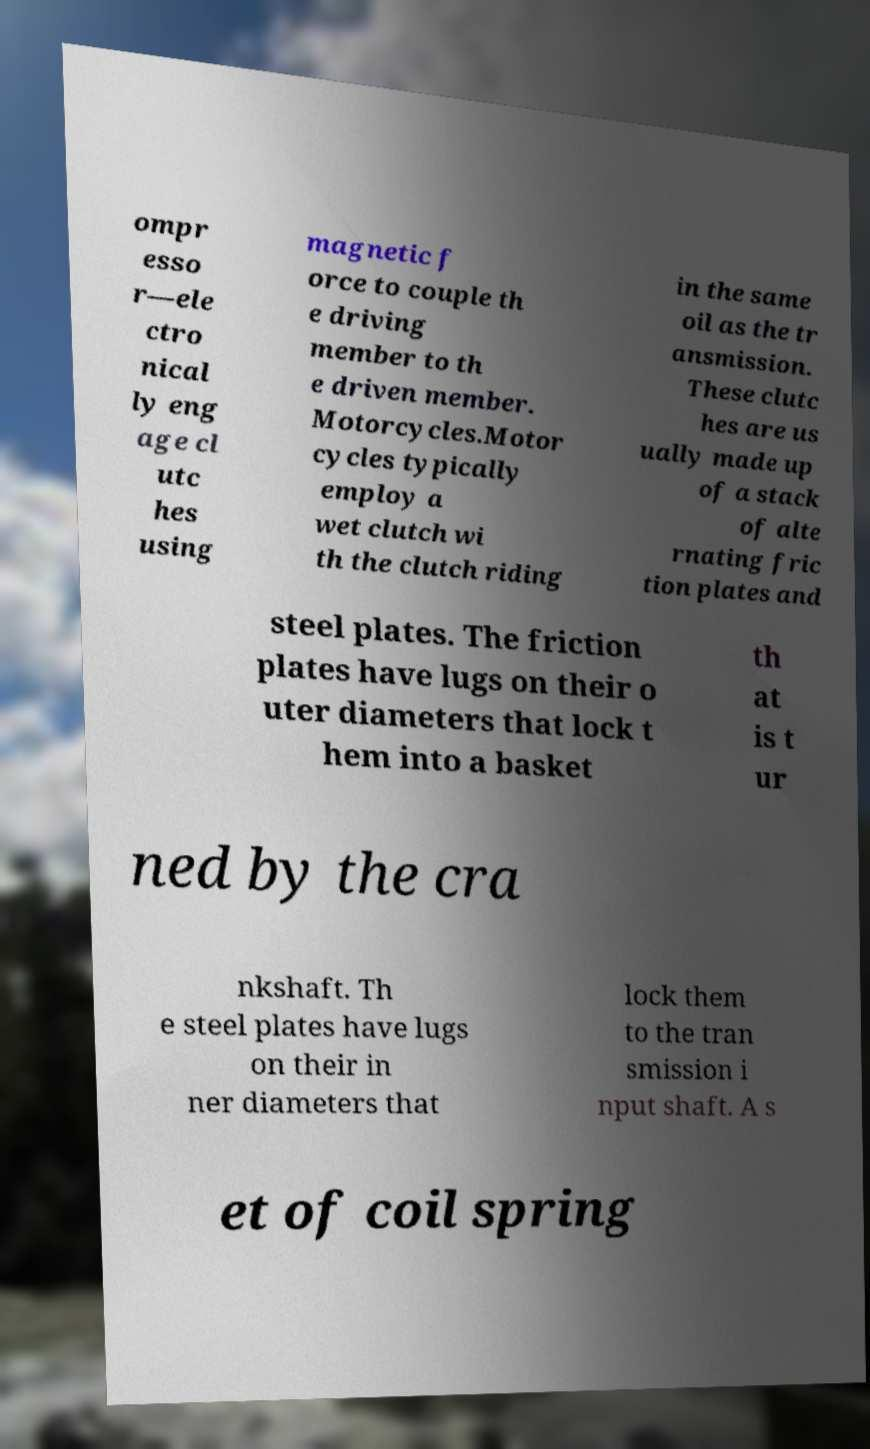Could you assist in decoding the text presented in this image and type it out clearly? ompr esso r—ele ctro nical ly eng age cl utc hes using magnetic f orce to couple th e driving member to th e driven member. Motorcycles.Motor cycles typically employ a wet clutch wi th the clutch riding in the same oil as the tr ansmission. These clutc hes are us ually made up of a stack of alte rnating fric tion plates and steel plates. The friction plates have lugs on their o uter diameters that lock t hem into a basket th at is t ur ned by the cra nkshaft. Th e steel plates have lugs on their in ner diameters that lock them to the tran smission i nput shaft. A s et of coil spring 